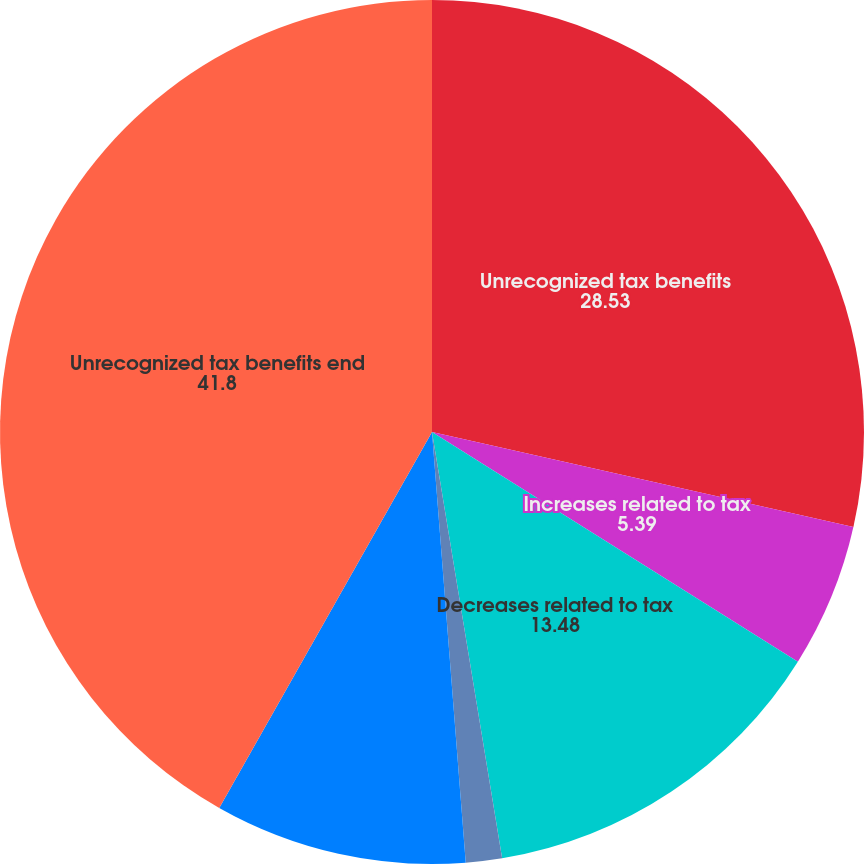<chart> <loc_0><loc_0><loc_500><loc_500><pie_chart><fcel>Unrecognized tax benefits<fcel>Increases related to tax<fcel>Decreases related to tax<fcel>Decreases related to<fcel>Reductions as a result of a<fcel>Unrecognized tax benefits end<nl><fcel>28.53%<fcel>5.39%<fcel>13.48%<fcel>1.35%<fcel>9.44%<fcel>41.8%<nl></chart> 